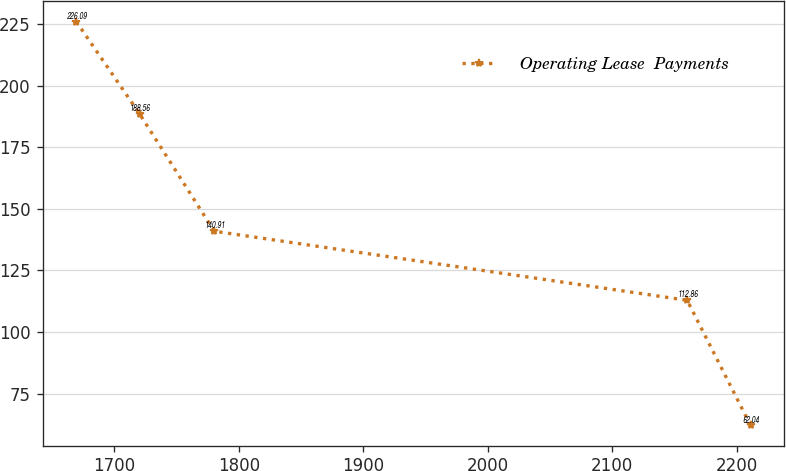Convert chart to OTSL. <chart><loc_0><loc_0><loc_500><loc_500><line_chart><ecel><fcel>Operating Lease  Payments<nl><fcel>1669.25<fcel>226.09<nl><fcel>1720.19<fcel>188.56<nl><fcel>1780.14<fcel>140.91<nl><fcel>2160.08<fcel>112.86<nl><fcel>2211.03<fcel>62.04<nl></chart> 